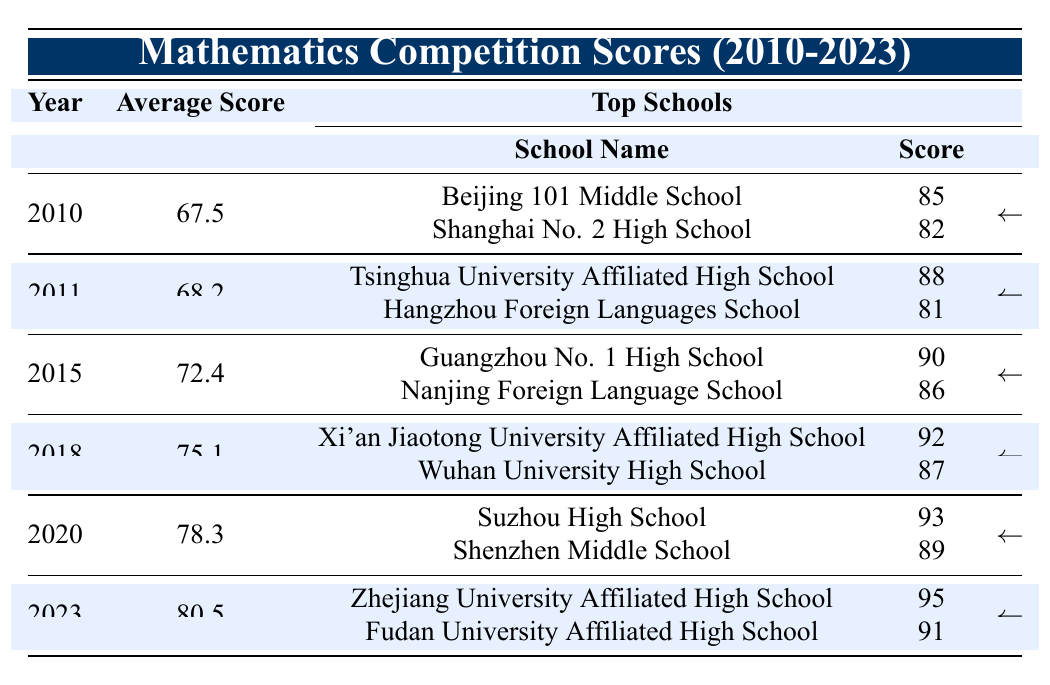What was the average score in 2010? The table lists 2010 in the year column, and the corresponding average score is 67.5.
Answer: 67.5 Which school had the highest score in 2023? In the year 2023, Zhejiang University Affiliated High School had the highest score listed, which is 95.
Answer: 95 What is the difference in average scores between 2010 and 2023? The average score in 2010 is 67.5 and in 2023 it is 80.5. The difference is calculated as 80.5 - 67.5 = 13.
Answer: 13 Did the average score increase from 2015 to 2018? The average score in 2015 is 72.4 and in 2018 it is 75.1. Since 75.1 is greater than 72.4, the average score did indeed increase.
Answer: Yes What is the average score across the years from 2010 to 2023? To find the average score, sum the average scores: 67.5 + 68.2 + 72.4 + 75.1 + 78.3 + 80.5 = 442. The number of years is 6, so the average is 442 / 6 ≈ 73.67.
Answer: 73.67 Which year had the lowest average score? Looking through the average scores listed by year, 2010 has the lowest average score of 67.5.
Answer: 2010 What percentage increase in average score was observed from 2011 to 2020? The average in 2011 is 68.2 and in 2020 it is 78.3. The increase is 78.3 - 68.2 = 10.1. To find the percentage increase, divide by the original score: (10.1 / 68.2) * 100 ≈ 14.81%.
Answer: 14.81% Did any school achieve a score of 90 or above in 2015? Yes, both Guangzhou No. 1 High School (90) and Nanjing Foreign Language School (86) were recognized in 2015, with Guangzhou No. 1 High School achieving the target score of 90 or more.
Answer: Yes What was the average score of the top 2 schools in 2020? The top schools in 2020 are Suzhou High School (93) and Shenzhen Middle School (89). The average is calculated as (93 + 89) / 2 = 91.
Answer: 91 